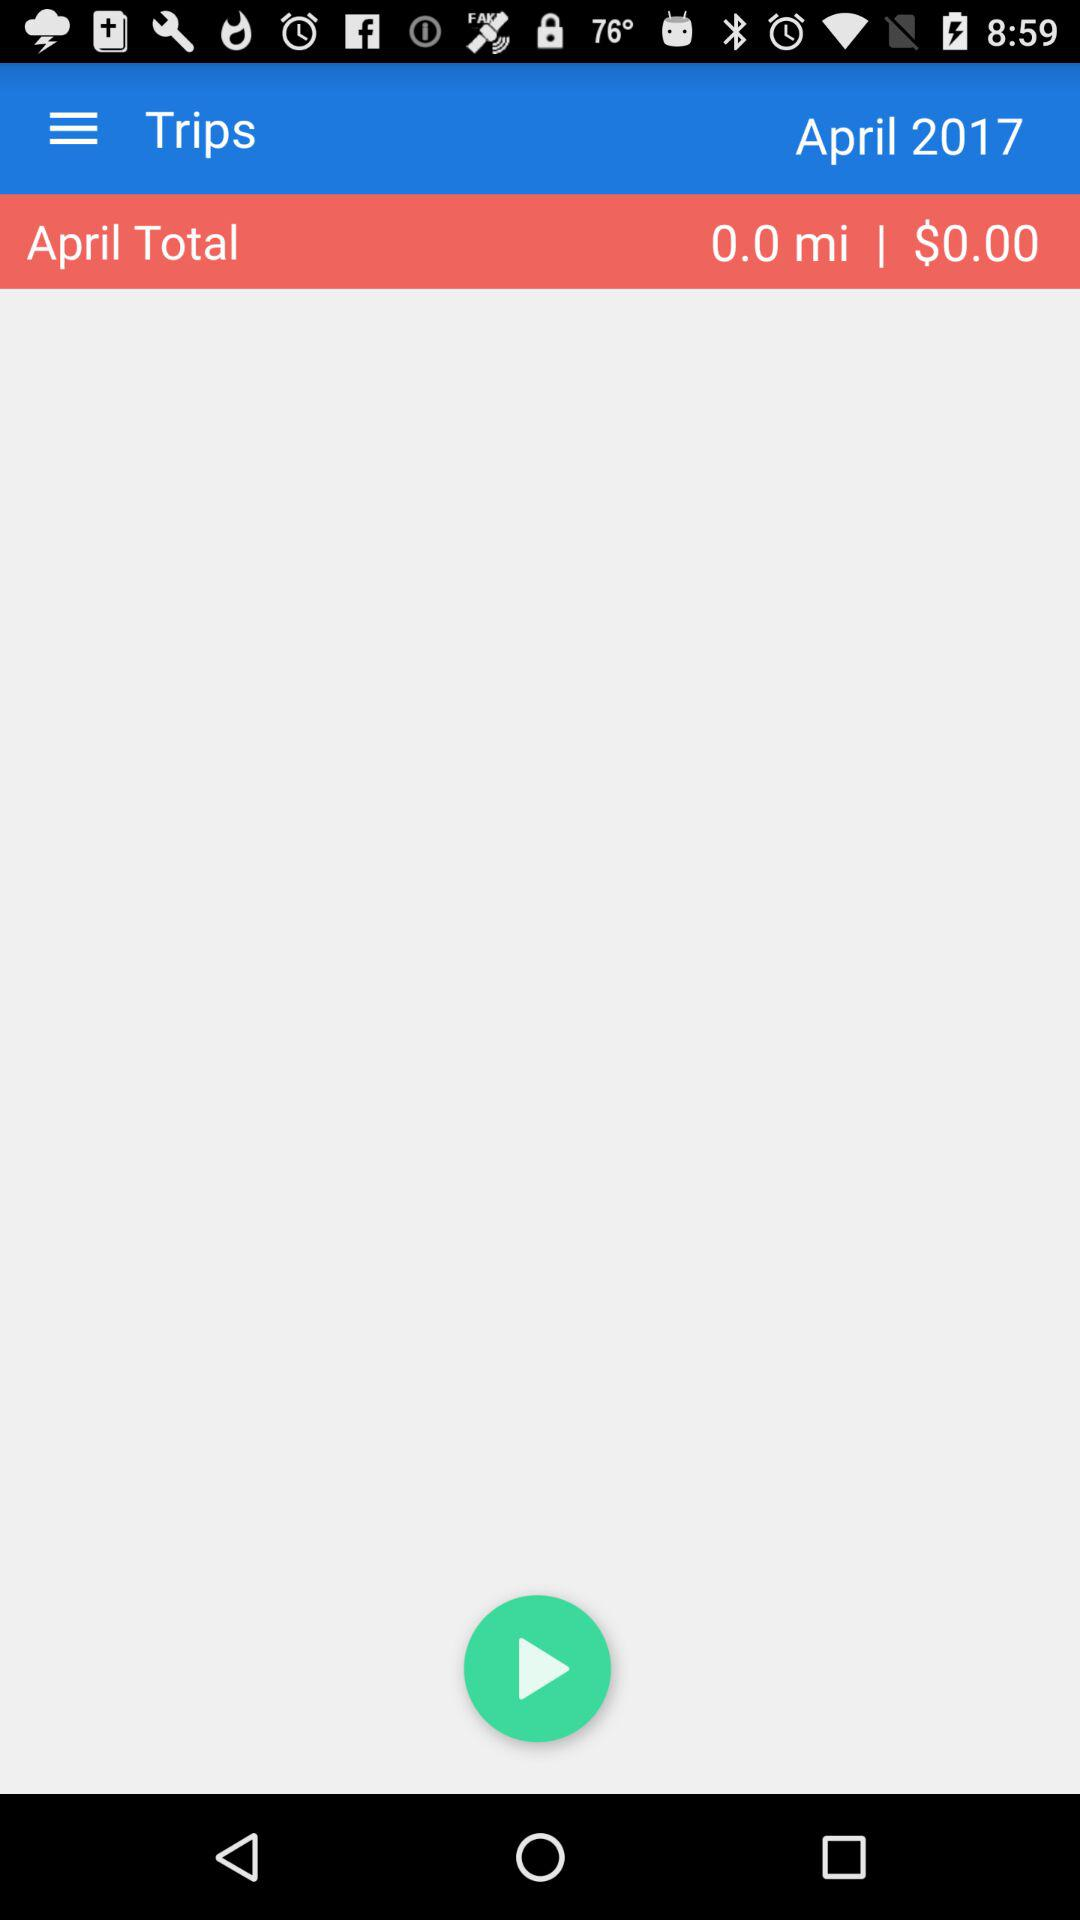Whose trips are these?
When the provided information is insufficient, respond with <no answer>. <no answer> 